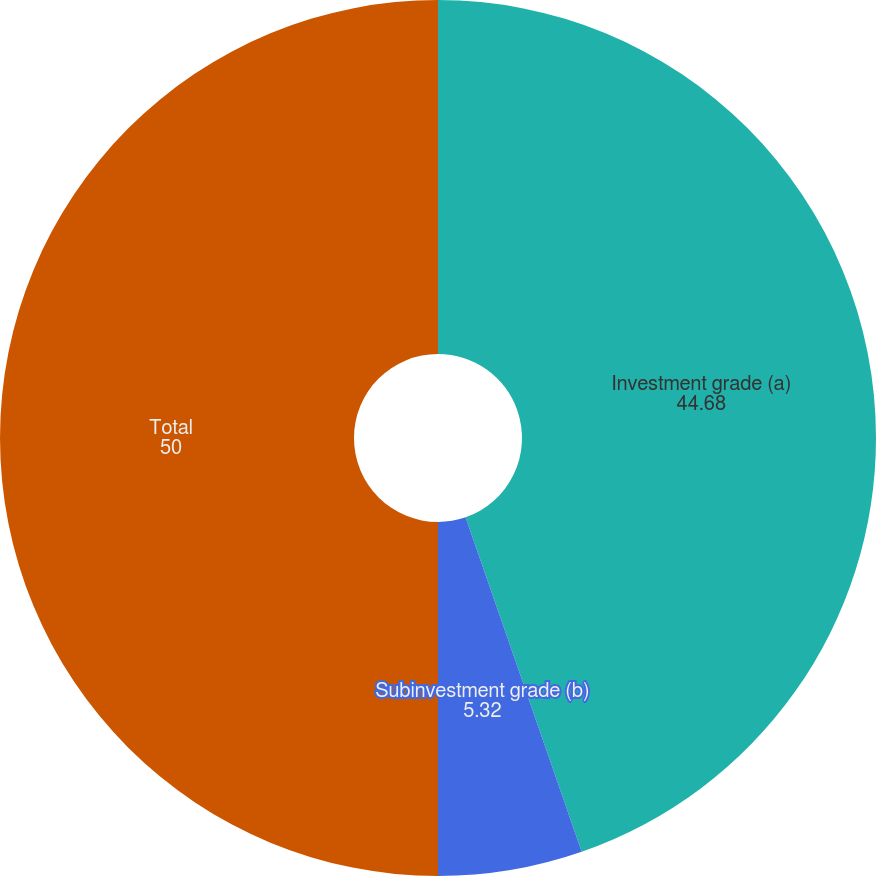<chart> <loc_0><loc_0><loc_500><loc_500><pie_chart><fcel>Investment grade (a)<fcel>Subinvestment grade (b)<fcel>Total<nl><fcel>44.68%<fcel>5.32%<fcel>50.0%<nl></chart> 